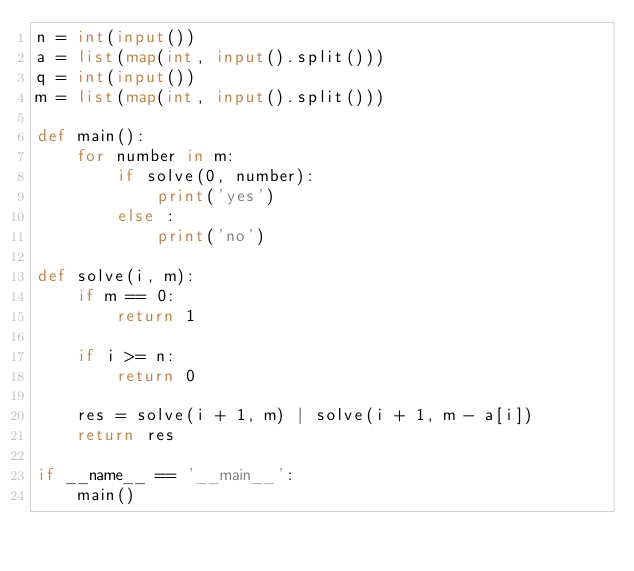<code> <loc_0><loc_0><loc_500><loc_500><_Python_>n = int(input())
a = list(map(int, input().split()))
q = int(input())
m = list(map(int, input().split()))

def main():
    for number in m:
        if solve(0, number):
            print('yes')
        else :
            print('no')

def solve(i, m):
    if m == 0:
        return 1

    if i >= n:
        return 0

    res = solve(i + 1, m) | solve(i + 1, m - a[i])
    return res

if __name__ == '__main__':
    main()

</code> 